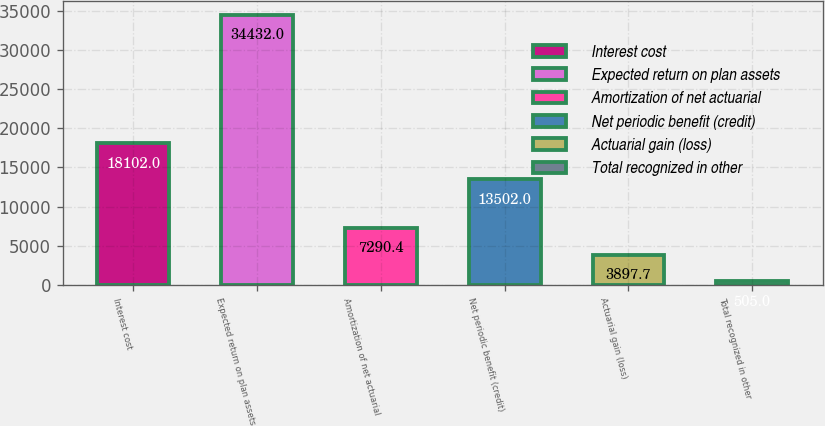<chart> <loc_0><loc_0><loc_500><loc_500><bar_chart><fcel>Interest cost<fcel>Expected return on plan assets<fcel>Amortization of net actuarial<fcel>Net periodic benefit (credit)<fcel>Actuarial gain (loss)<fcel>Total recognized in other<nl><fcel>18102<fcel>34432<fcel>7290.4<fcel>13502<fcel>3897.7<fcel>505<nl></chart> 